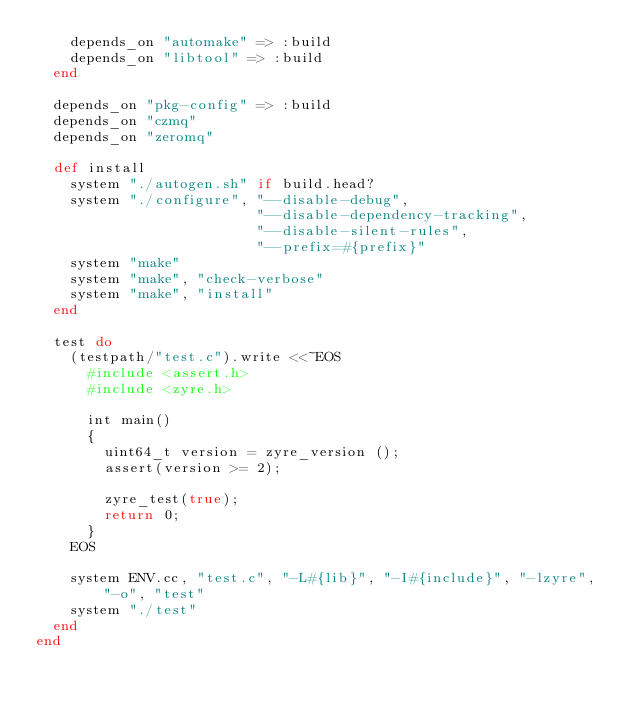Convert code to text. <code><loc_0><loc_0><loc_500><loc_500><_Ruby_>    depends_on "automake" => :build
    depends_on "libtool" => :build
  end

  depends_on "pkg-config" => :build
  depends_on "czmq"
  depends_on "zeromq"

  def install
    system "./autogen.sh" if build.head?
    system "./configure", "--disable-debug",
                          "--disable-dependency-tracking",
                          "--disable-silent-rules",
                          "--prefix=#{prefix}"
    system "make"
    system "make", "check-verbose"
    system "make", "install"
  end

  test do
    (testpath/"test.c").write <<~EOS
      #include <assert.h>
      #include <zyre.h>

      int main()
      {
        uint64_t version = zyre_version ();
        assert(version >= 2);

        zyre_test(true);
        return 0;
      }
    EOS

    system ENV.cc, "test.c", "-L#{lib}", "-I#{include}", "-lzyre", "-o", "test"
    system "./test"
  end
end
</code> 